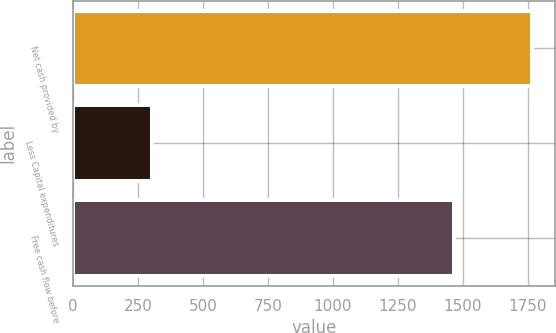Convert chart. <chart><loc_0><loc_0><loc_500><loc_500><bar_chart><fcel>Net cash provided by<fcel>Less Capital expenditures<fcel>Free cash flow before<nl><fcel>1767.7<fcel>302.1<fcel>1465.6<nl></chart> 